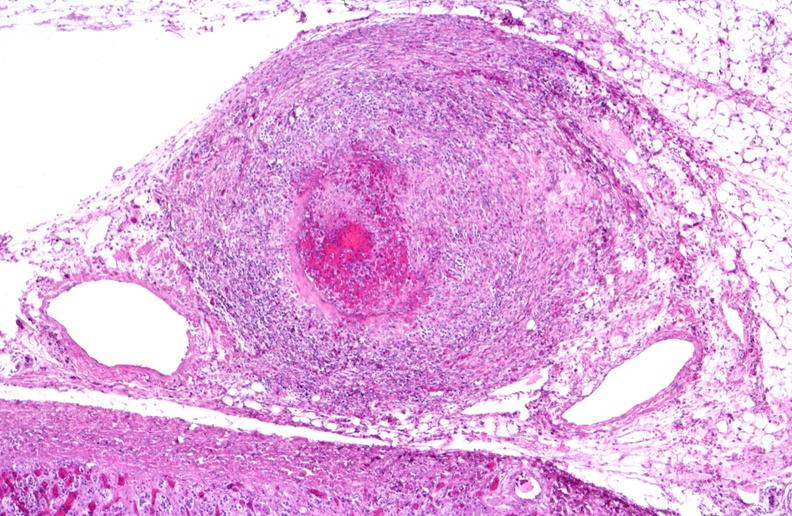where is this from?
Answer the question using a single word or phrase. Vasculature 